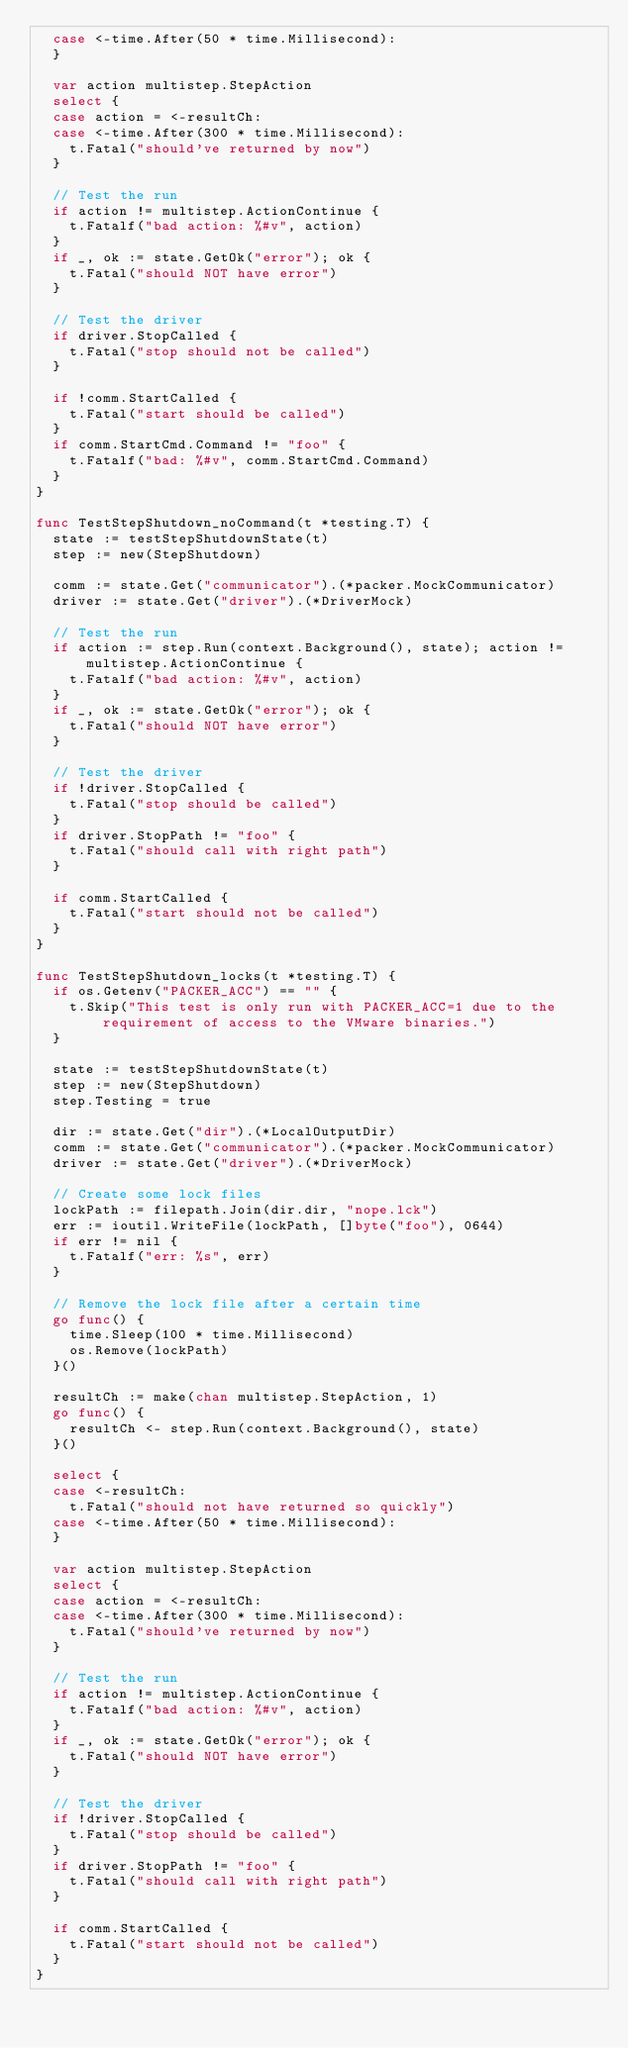Convert code to text. <code><loc_0><loc_0><loc_500><loc_500><_Go_>	case <-time.After(50 * time.Millisecond):
	}

	var action multistep.StepAction
	select {
	case action = <-resultCh:
	case <-time.After(300 * time.Millisecond):
		t.Fatal("should've returned by now")
	}

	// Test the run
	if action != multistep.ActionContinue {
		t.Fatalf("bad action: %#v", action)
	}
	if _, ok := state.GetOk("error"); ok {
		t.Fatal("should NOT have error")
	}

	// Test the driver
	if driver.StopCalled {
		t.Fatal("stop should not be called")
	}

	if !comm.StartCalled {
		t.Fatal("start should be called")
	}
	if comm.StartCmd.Command != "foo" {
		t.Fatalf("bad: %#v", comm.StartCmd.Command)
	}
}

func TestStepShutdown_noCommand(t *testing.T) {
	state := testStepShutdownState(t)
	step := new(StepShutdown)

	comm := state.Get("communicator").(*packer.MockCommunicator)
	driver := state.Get("driver").(*DriverMock)

	// Test the run
	if action := step.Run(context.Background(), state); action != multistep.ActionContinue {
		t.Fatalf("bad action: %#v", action)
	}
	if _, ok := state.GetOk("error"); ok {
		t.Fatal("should NOT have error")
	}

	// Test the driver
	if !driver.StopCalled {
		t.Fatal("stop should be called")
	}
	if driver.StopPath != "foo" {
		t.Fatal("should call with right path")
	}

	if comm.StartCalled {
		t.Fatal("start should not be called")
	}
}

func TestStepShutdown_locks(t *testing.T) {
	if os.Getenv("PACKER_ACC") == "" {
		t.Skip("This test is only run with PACKER_ACC=1 due to the requirement of access to the VMware binaries.")
	}

	state := testStepShutdownState(t)
	step := new(StepShutdown)
	step.Testing = true

	dir := state.Get("dir").(*LocalOutputDir)
	comm := state.Get("communicator").(*packer.MockCommunicator)
	driver := state.Get("driver").(*DriverMock)

	// Create some lock files
	lockPath := filepath.Join(dir.dir, "nope.lck")
	err := ioutil.WriteFile(lockPath, []byte("foo"), 0644)
	if err != nil {
		t.Fatalf("err: %s", err)
	}

	// Remove the lock file after a certain time
	go func() {
		time.Sleep(100 * time.Millisecond)
		os.Remove(lockPath)
	}()

	resultCh := make(chan multistep.StepAction, 1)
	go func() {
		resultCh <- step.Run(context.Background(), state)
	}()

	select {
	case <-resultCh:
		t.Fatal("should not have returned so quickly")
	case <-time.After(50 * time.Millisecond):
	}

	var action multistep.StepAction
	select {
	case action = <-resultCh:
	case <-time.After(300 * time.Millisecond):
		t.Fatal("should've returned by now")
	}

	// Test the run
	if action != multistep.ActionContinue {
		t.Fatalf("bad action: %#v", action)
	}
	if _, ok := state.GetOk("error"); ok {
		t.Fatal("should NOT have error")
	}

	// Test the driver
	if !driver.StopCalled {
		t.Fatal("stop should be called")
	}
	if driver.StopPath != "foo" {
		t.Fatal("should call with right path")
	}

	if comm.StartCalled {
		t.Fatal("start should not be called")
	}
}
</code> 